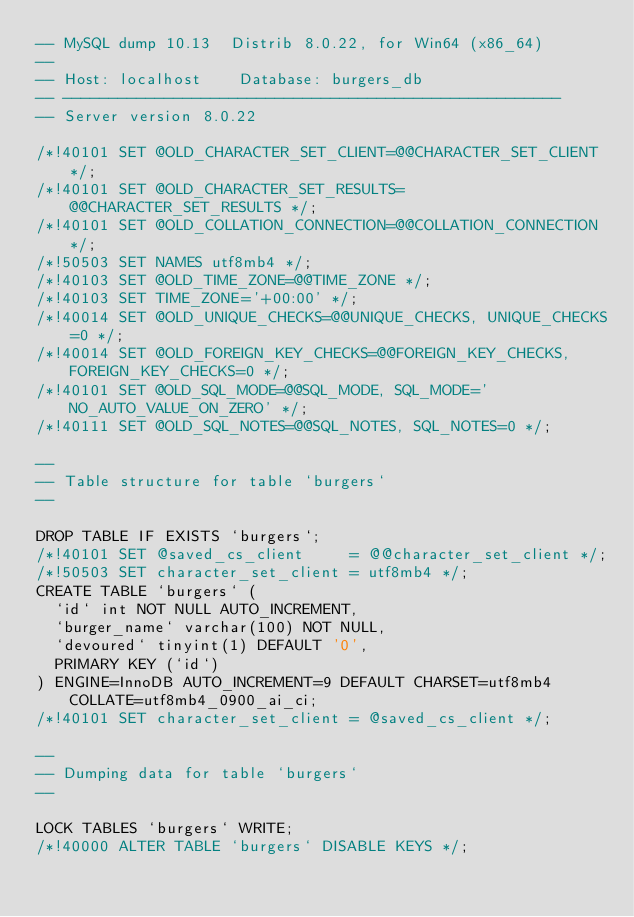<code> <loc_0><loc_0><loc_500><loc_500><_SQL_>-- MySQL dump 10.13  Distrib 8.0.22, for Win64 (x86_64)
--
-- Host: localhost    Database: burgers_db
-- ------------------------------------------------------
-- Server version	8.0.22

/*!40101 SET @OLD_CHARACTER_SET_CLIENT=@@CHARACTER_SET_CLIENT */;
/*!40101 SET @OLD_CHARACTER_SET_RESULTS=@@CHARACTER_SET_RESULTS */;
/*!40101 SET @OLD_COLLATION_CONNECTION=@@COLLATION_CONNECTION */;
/*!50503 SET NAMES utf8mb4 */;
/*!40103 SET @OLD_TIME_ZONE=@@TIME_ZONE */;
/*!40103 SET TIME_ZONE='+00:00' */;
/*!40014 SET @OLD_UNIQUE_CHECKS=@@UNIQUE_CHECKS, UNIQUE_CHECKS=0 */;
/*!40014 SET @OLD_FOREIGN_KEY_CHECKS=@@FOREIGN_KEY_CHECKS, FOREIGN_KEY_CHECKS=0 */;
/*!40101 SET @OLD_SQL_MODE=@@SQL_MODE, SQL_MODE='NO_AUTO_VALUE_ON_ZERO' */;
/*!40111 SET @OLD_SQL_NOTES=@@SQL_NOTES, SQL_NOTES=0 */;

--
-- Table structure for table `burgers`
--

DROP TABLE IF EXISTS `burgers`;
/*!40101 SET @saved_cs_client     = @@character_set_client */;
/*!50503 SET character_set_client = utf8mb4 */;
CREATE TABLE `burgers` (
  `id` int NOT NULL AUTO_INCREMENT,
  `burger_name` varchar(100) NOT NULL,
  `devoured` tinyint(1) DEFAULT '0',
  PRIMARY KEY (`id`)
) ENGINE=InnoDB AUTO_INCREMENT=9 DEFAULT CHARSET=utf8mb4 COLLATE=utf8mb4_0900_ai_ci;
/*!40101 SET character_set_client = @saved_cs_client */;

--
-- Dumping data for table `burgers`
--

LOCK TABLES `burgers` WRITE;
/*!40000 ALTER TABLE `burgers` DISABLE KEYS */;</code> 